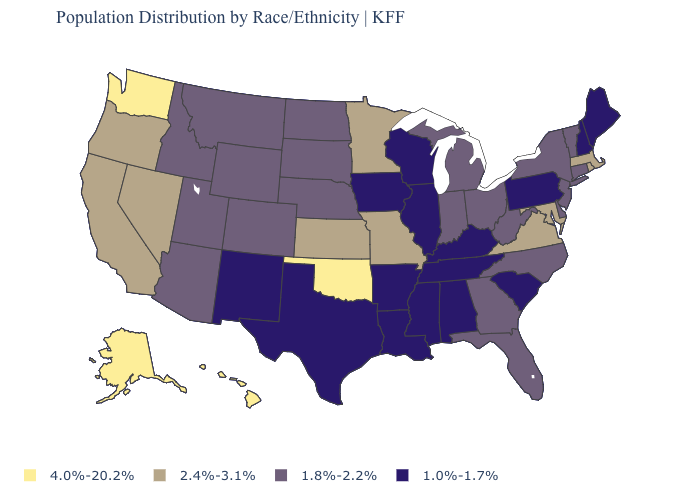Name the states that have a value in the range 4.0%-20.2%?
Answer briefly. Alaska, Hawaii, Oklahoma, Washington. What is the value of California?
Give a very brief answer. 2.4%-3.1%. What is the value of West Virginia?
Short answer required. 1.8%-2.2%. What is the value of Illinois?
Write a very short answer. 1.0%-1.7%. Name the states that have a value in the range 2.4%-3.1%?
Give a very brief answer. California, Kansas, Maryland, Massachusetts, Minnesota, Missouri, Nevada, Oregon, Rhode Island, Virginia. Name the states that have a value in the range 1.8%-2.2%?
Write a very short answer. Arizona, Colorado, Connecticut, Delaware, Florida, Georgia, Idaho, Indiana, Michigan, Montana, Nebraska, New Jersey, New York, North Carolina, North Dakota, Ohio, South Dakota, Utah, Vermont, West Virginia, Wyoming. Does Louisiana have the highest value in the USA?
Short answer required. No. What is the value of Tennessee?
Answer briefly. 1.0%-1.7%. What is the highest value in states that border Pennsylvania?
Write a very short answer. 2.4%-3.1%. Does Rhode Island have the lowest value in the Northeast?
Answer briefly. No. Which states have the lowest value in the USA?
Quick response, please. Alabama, Arkansas, Illinois, Iowa, Kentucky, Louisiana, Maine, Mississippi, New Hampshire, New Mexico, Pennsylvania, South Carolina, Tennessee, Texas, Wisconsin. Which states hav the highest value in the South?
Be succinct. Oklahoma. Which states have the lowest value in the South?
Answer briefly. Alabama, Arkansas, Kentucky, Louisiana, Mississippi, South Carolina, Tennessee, Texas. What is the value of Louisiana?
Quick response, please. 1.0%-1.7%. 